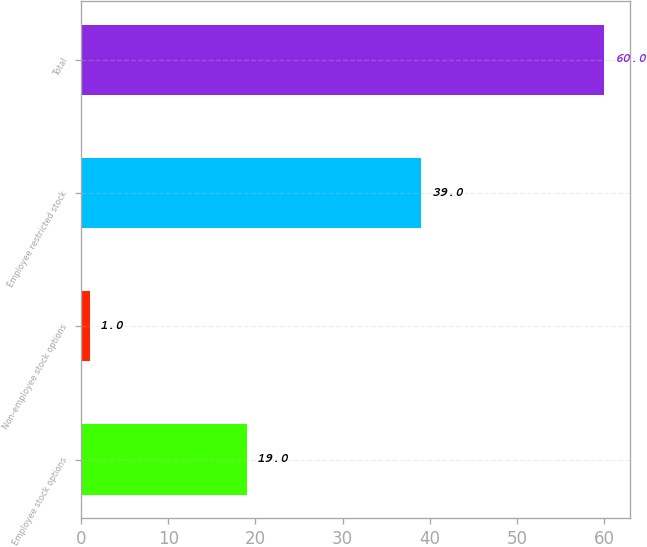<chart> <loc_0><loc_0><loc_500><loc_500><bar_chart><fcel>Employee stock options<fcel>Non-employee stock options<fcel>Employee restricted stock<fcel>Total<nl><fcel>19<fcel>1<fcel>39<fcel>60<nl></chart> 